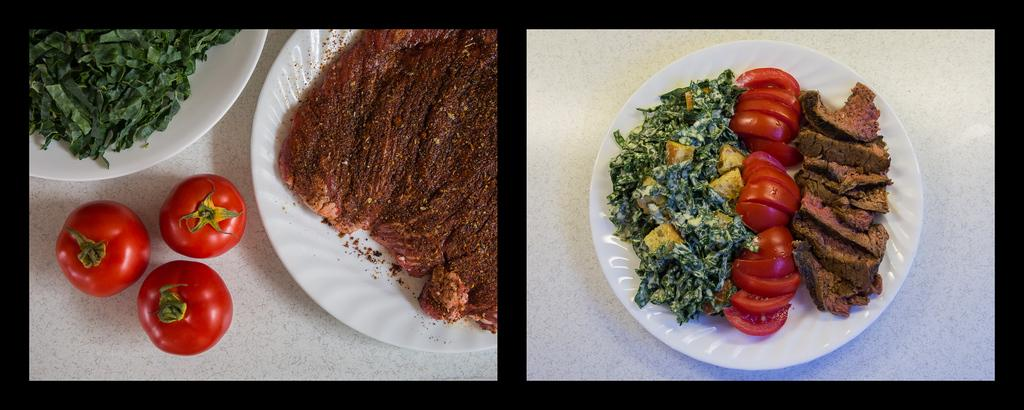What type of artwork is the image? The image is a collage. What can be seen on the plates in the image? There are food items on plates in the image. How many tomatoes are visible in the image? There are three tomatoes on an object in the image. What color is the map in the image? There is no map present in the image. 